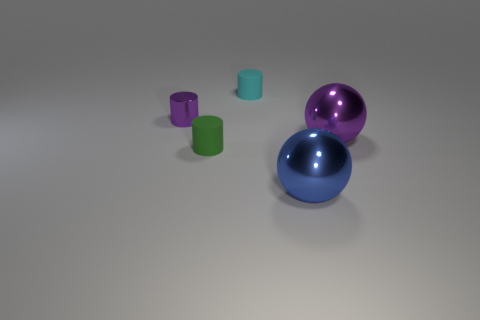Subtract all rubber cylinders. How many cylinders are left? 1 Add 1 small brown rubber cylinders. How many objects exist? 6 Subtract all yellow cylinders. Subtract all yellow spheres. How many cylinders are left? 3 Subtract all cylinders. How many objects are left? 2 Add 5 shiny cylinders. How many shiny cylinders are left? 6 Add 1 small purple metallic things. How many small purple metallic things exist? 2 Subtract 0 yellow cylinders. How many objects are left? 5 Subtract all large spheres. Subtract all blue metallic spheres. How many objects are left? 2 